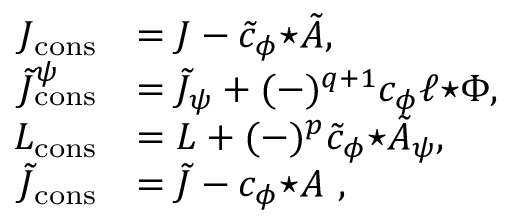<formula> <loc_0><loc_0><loc_500><loc_500>\begin{array} { r l } { J _ { c o n s } } & { = J - \tilde { c } _ { \phi } { ^ { * } \tilde { A } } , } \\ { \tilde { J } _ { c o n s } ^ { \psi } } & { = \tilde { J } _ { \psi } + ( - ) ^ { q + 1 } c _ { \phi } \ell { ^ { * } \Phi } , } \\ { L _ { c o n s } } & { = L + ( - ) ^ { p } \tilde { c } _ { \phi } { ^ { * } \tilde { A } _ { \psi } } , } \\ { \tilde { J } _ { c o n s } } & { = \tilde { J } - c _ { \phi } { ^ { * } A } , } \end{array}</formula> 